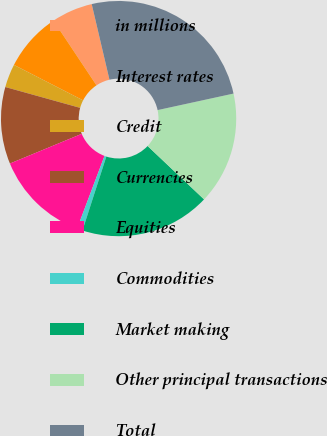<chart> <loc_0><loc_0><loc_500><loc_500><pie_chart><fcel>in millions<fcel>Interest rates<fcel>Credit<fcel>Currencies<fcel>Equities<fcel>Commodities<fcel>Market making<fcel>Other principal transactions<fcel>Total<nl><fcel>5.67%<fcel>8.12%<fcel>3.22%<fcel>10.57%<fcel>13.02%<fcel>0.77%<fcel>17.92%<fcel>15.47%<fcel>25.27%<nl></chart> 